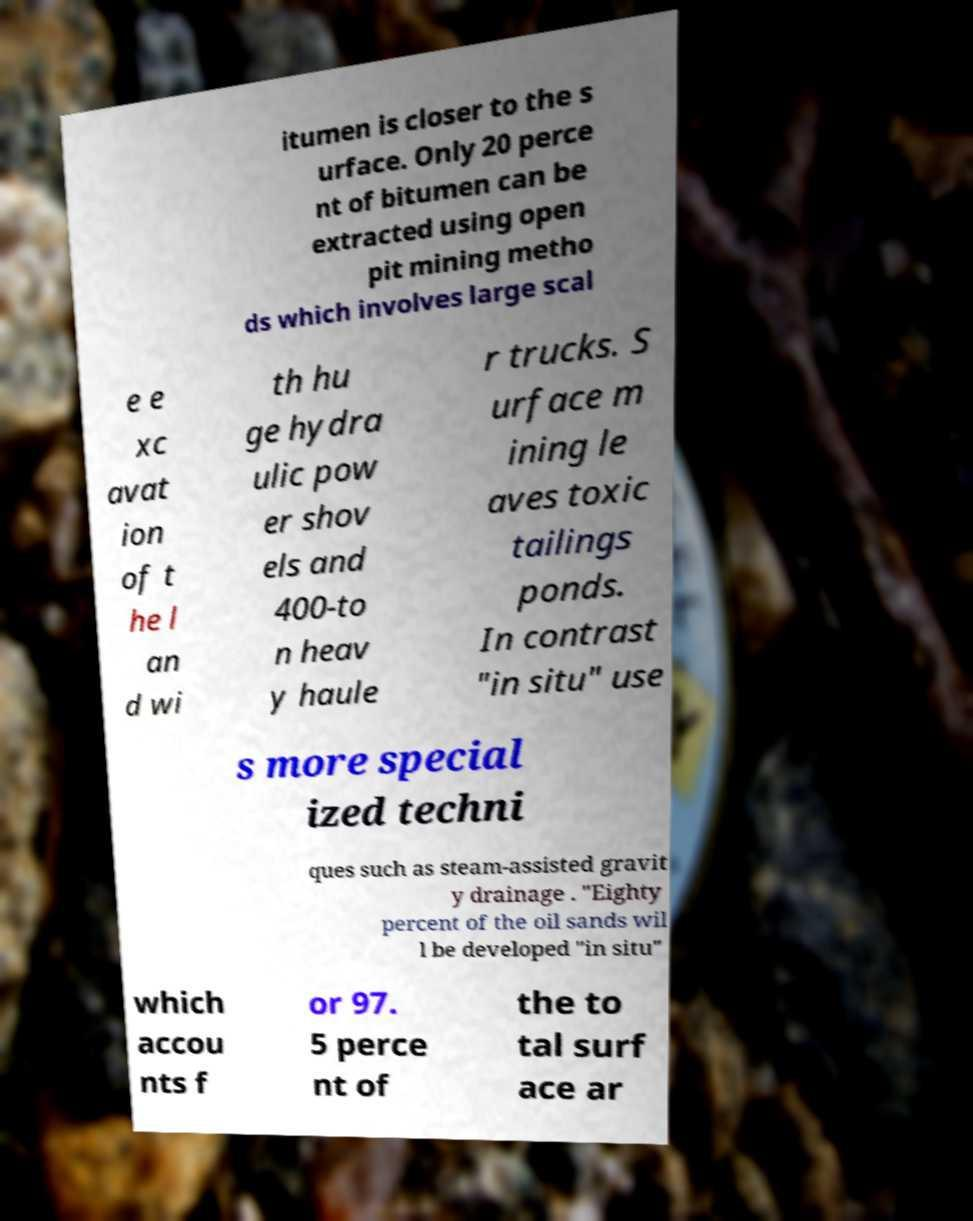Could you assist in decoding the text presented in this image and type it out clearly? itumen is closer to the s urface. Only 20 perce nt of bitumen can be extracted using open pit mining metho ds which involves large scal e e xc avat ion of t he l an d wi th hu ge hydra ulic pow er shov els and 400-to n heav y haule r trucks. S urface m ining le aves toxic tailings ponds. In contrast "in situ" use s more special ized techni ques such as steam-assisted gravit y drainage . "Eighty percent of the oil sands wil l be developed "in situ" which accou nts f or 97. 5 perce nt of the to tal surf ace ar 